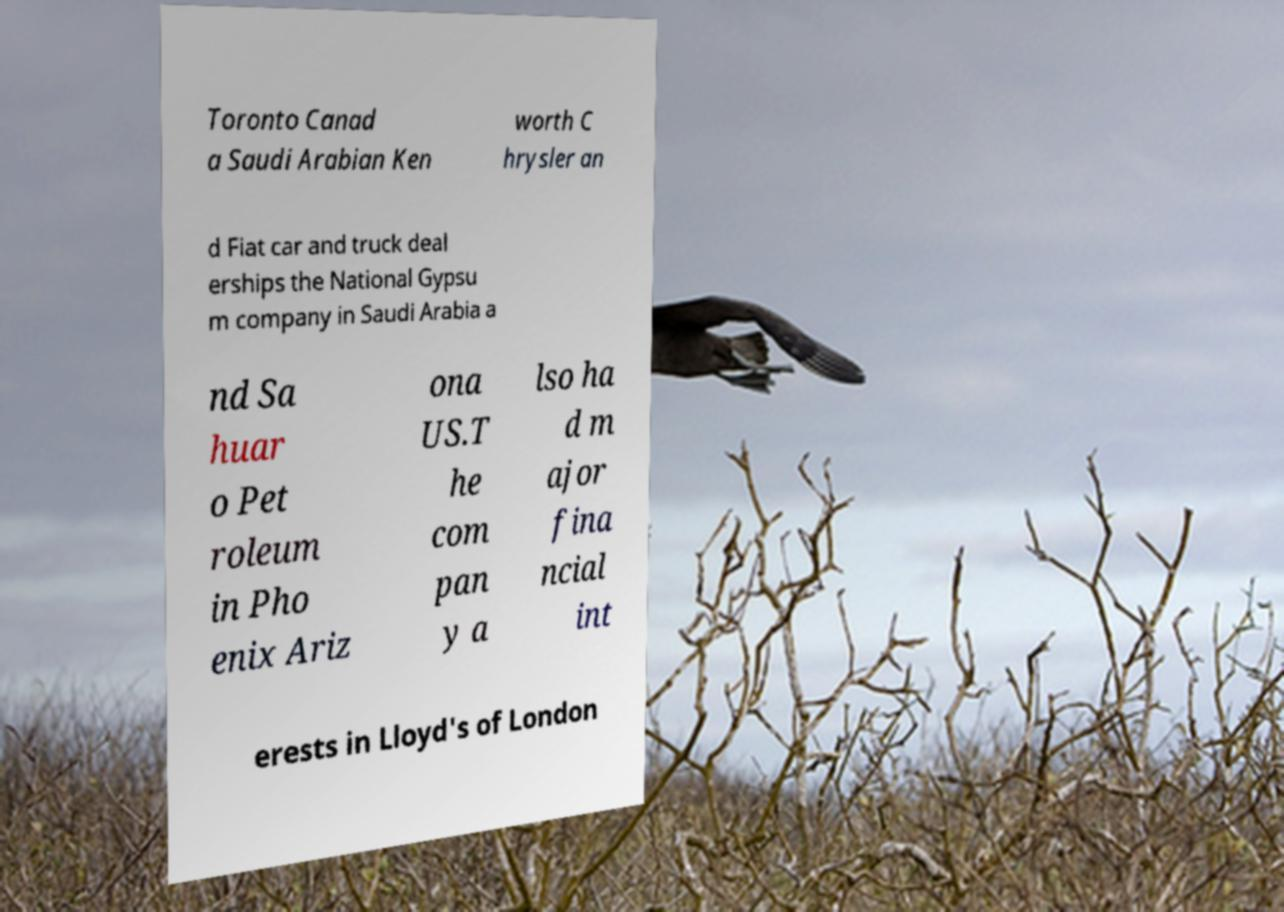I need the written content from this picture converted into text. Can you do that? Toronto Canad a Saudi Arabian Ken worth C hrysler an d Fiat car and truck deal erships the National Gypsu m company in Saudi Arabia a nd Sa huar o Pet roleum in Pho enix Ariz ona US.T he com pan y a lso ha d m ajor fina ncial int erests in Lloyd's of London 